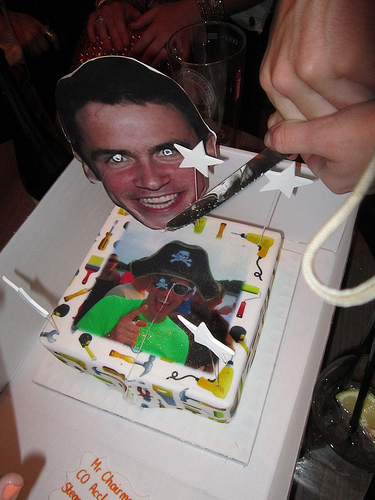Please provide a short description for this region: [0.23, 0.88, 0.38, 0.99]. Orange writing by cake. Please provide the bounding box coordinate of the region this sentence describes: a beer glass from a restaurant. [0.45, 0.04, 0.62, 0.29] Please provide the bounding box coordinate of the region this sentence describes: two stars spread apart in photo. [0.13, 0.54, 0.58, 0.76] Please provide a short description for this region: [0.23, 0.11, 0.56, 0.46]. A cut out of someones smiling face. Please provide the bounding box coordinate of the region this sentence describes: a white star cake decoration. [0.47, 0.28, 0.57, 0.36] Please provide the bounding box coordinate of the region this sentence describes: man smiling on cake. [0.38, 0.5, 0.52, 0.77] Please provide a short description for this region: [0.27, 0.46, 0.58, 0.75]. Person points with finger. Please provide the bounding box coordinate of the region this sentence describes: The image of a a pirate painted on a cake. [0.25, 0.48, 0.57, 0.74] Please provide the bounding box coordinate of the region this sentence describes: cake with tools on it. [0.32, 0.41, 0.62, 0.86] Please provide the bounding box coordinate of the region this sentence describes: Eyes of person. [0.32, 0.29, 0.48, 0.34] 